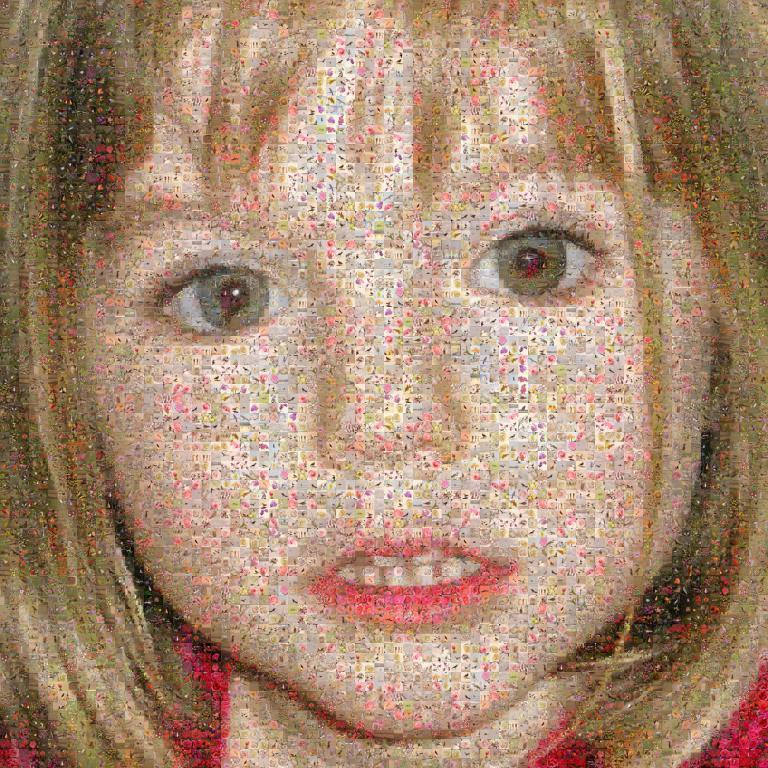What type of image is being depicted? The image is an edited image of a person. What type of dinosaurs can be seen in the image? There are no dinosaurs present in the image; it is an edited image of a person. What type of smell is associated with the person in the image? There is no information about the smell associated with the person in the image, as it is a visual medium. 